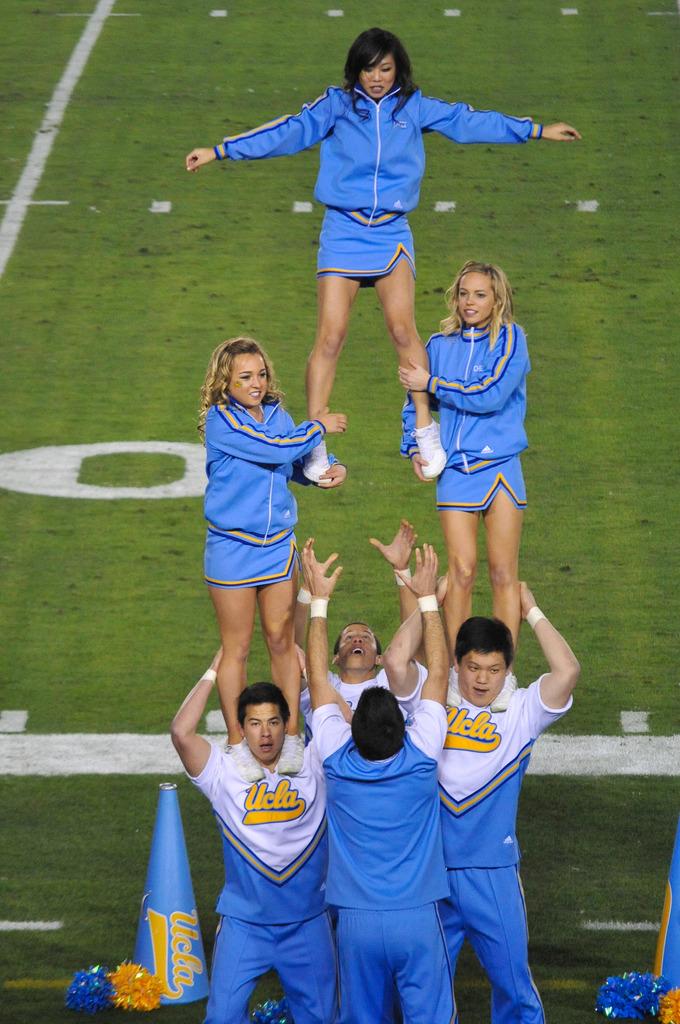What is the school name on their uniforms?
Give a very brief answer. Ucla. Who do the cheerleaders represent?
Offer a terse response. Ucla. 